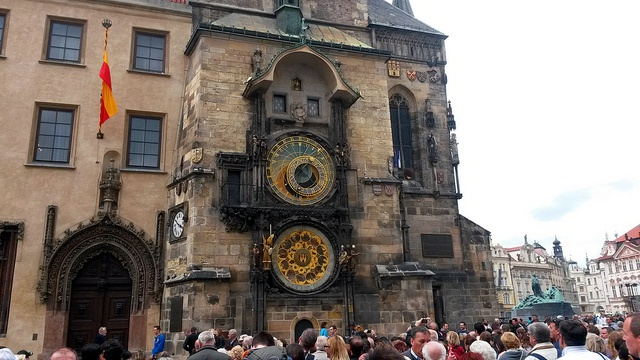Describe the objects in this image and their specific colors. I can see people in gray, black, and maroon tones, clock in gray, black, olive, and tan tones, people in gray, black, white, and darkgray tones, people in gray, brown, maroon, and lightpink tones, and people in gray, black, and darkgray tones in this image. 